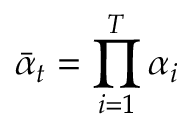Convert formula to latex. <formula><loc_0><loc_0><loc_500><loc_500>\bar { \alpha } _ { t } = \prod _ { i = 1 } ^ { T } \alpha _ { i }</formula> 